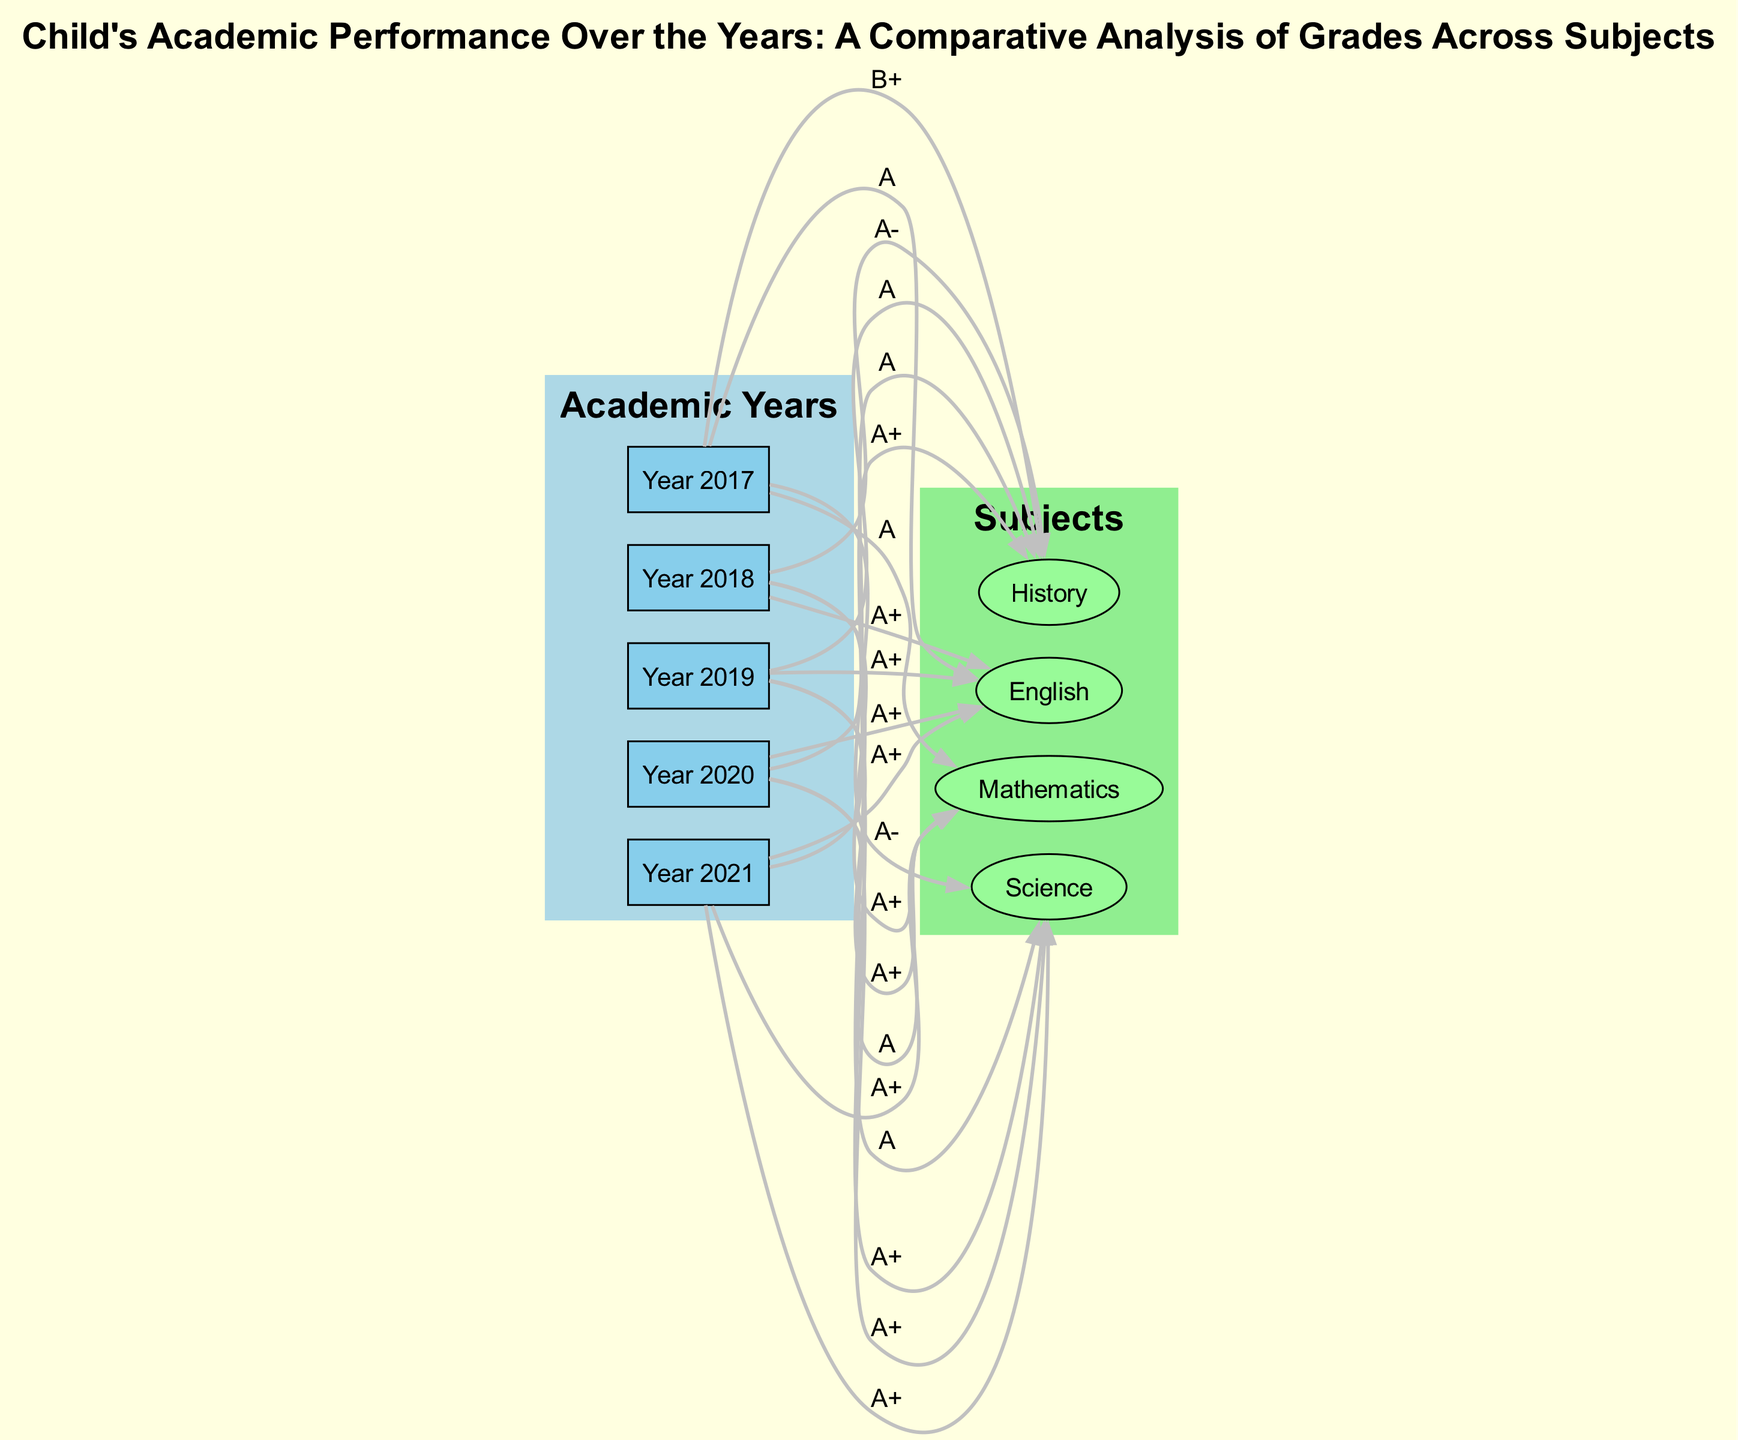What were the grades in Mathematics in Year 2019? The diagram indicates that the grade for Mathematics in Year 2019 is A+. This is found by tracing the edge from Year 2019 to the Mathematics node, which has a label of A+.
Answer: A+ Which subject had the lowest grade in Year 2017? In the diagram, the grades for Year 2017 are A for Mathematics, A- for Science, B+ for History, and A for English. The lowest grade corresponds to History, labeled as B+.
Answer: History How many subjects are represented in the diagram? The diagram includes four subjects: Mathematics, Science, History, and English. This is determined by counting the unique subject nodes present in the diagram.
Answer: Four What improvement did the child make in Science from Year 2017 to Year 2021? In Year 2017, the grade for Science was A-, and by Year 2021, the grade improved to A+. This indicates a progression from A- to A+, evidencing an improvement.
Answer: Improved Which year had all subjects graded as A or higher? Year 2019 had all subjects graded as A or higher: A+ for Mathematics, A+ for Science, A for History, and A+ for English. This is verified by reviewing each subject's grade in this year.
Answer: Year 2019 Which year had the highest overall grades across all subjects? Year 2021 had the highest grades across all subjects, all receiving A+. This conclusion is reached by analyzing that both Mathematics, Science, History, and English in Year 2021 are labeled A+.
Answer: Year 2021 What was the trend for English grades from Year 2017 to Year 2021? The grades for English were A in Year 2017, A+ in Year 2018, A+ in Year 2019, A+ in Year 2020, and A+ in Year 2021. The trend displays consistent improvement from A to A+ and remaining A+.
Answer: Improved In which subject did the child secure the lowest grade overall? The lowest grade overall was found in History, with a grade of B+ in Year 2017. This is confirmed by examining all edges leading to History and finding the lowest label.
Answer: History 